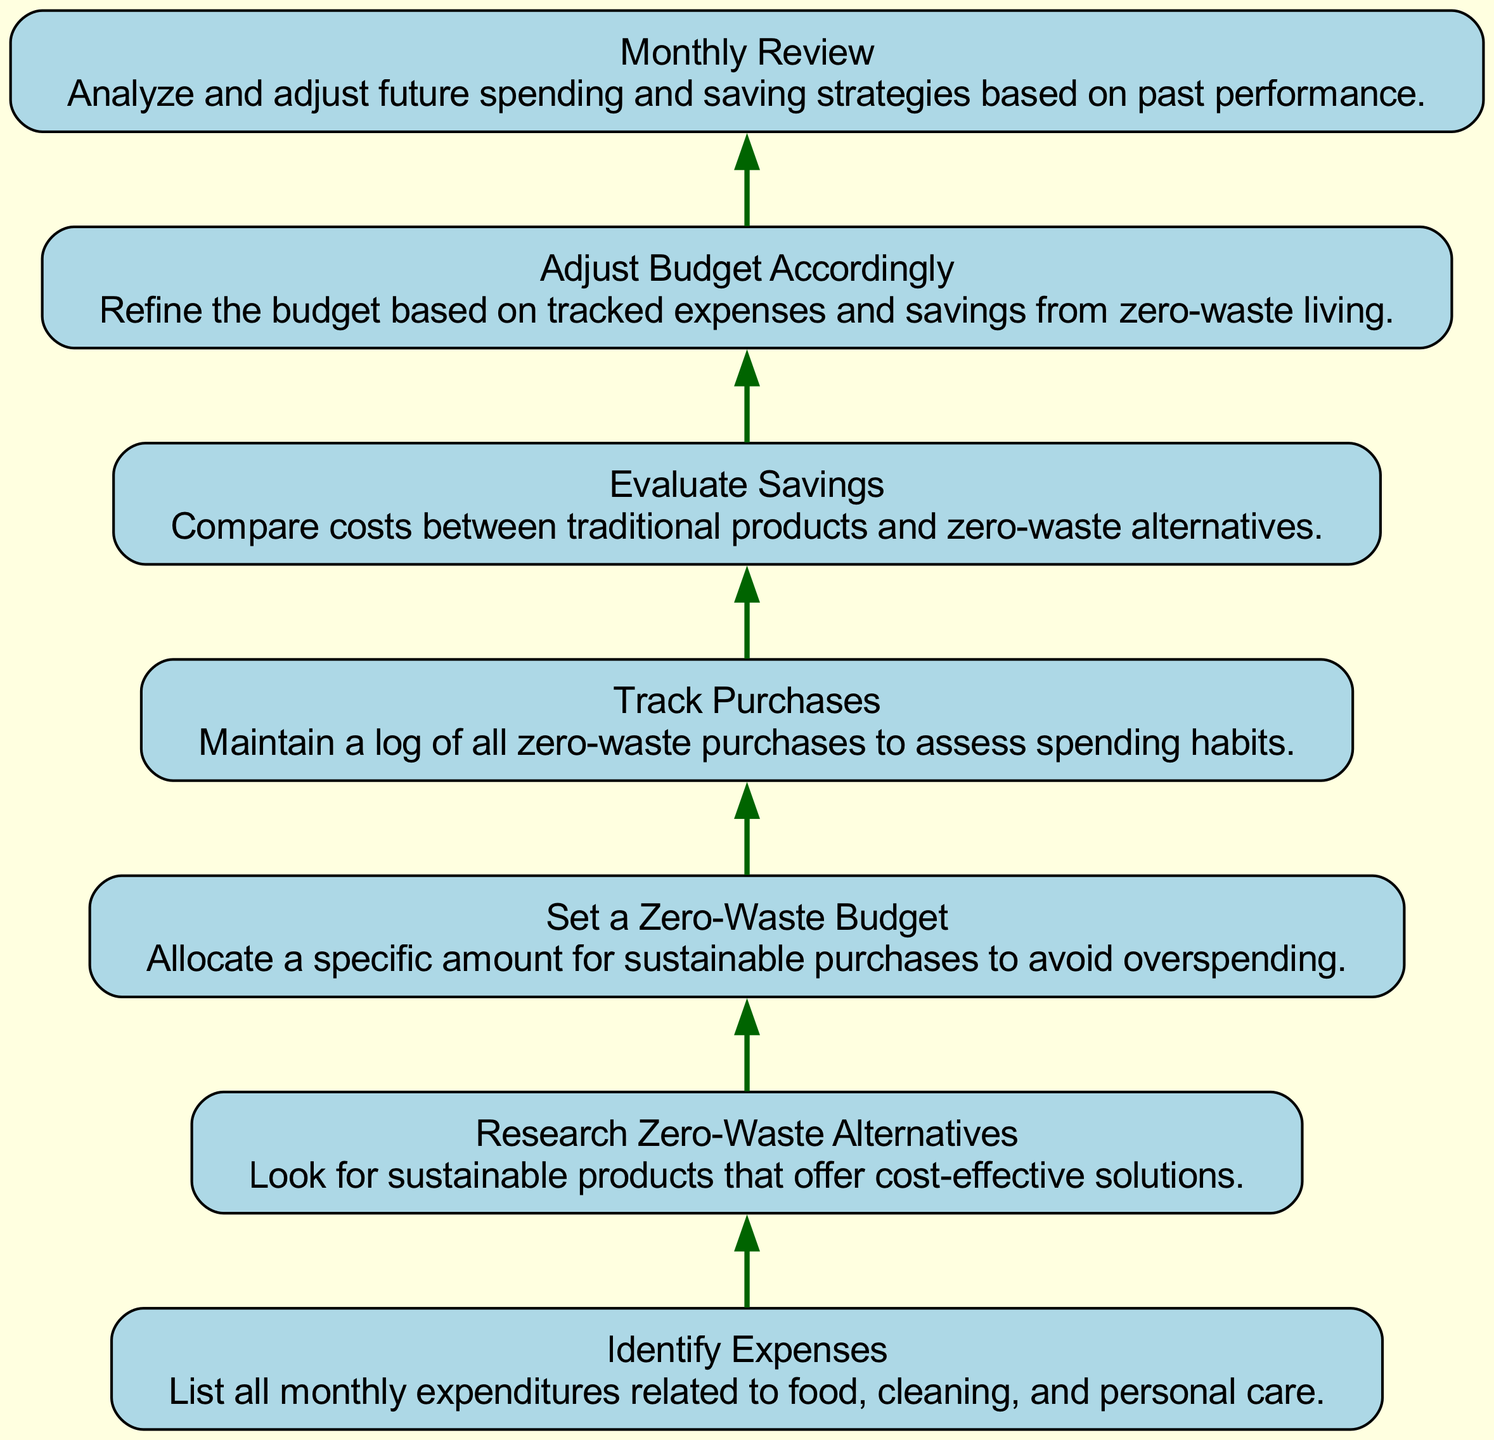What is the first step in budgeting for a zero-waste lifestyle? The first step is to identify all monthly expenses related to food, cleaning, and personal care, as indicated by the first node in the flow chart.
Answer: Identify Expenses How many nodes are in the diagram? There are seven distinct nodes representing different steps in the budgeting process for a zero-waste lifestyle.
Answer: Seven What is the last step mentioned in the flow chart? The last step is to conduct a monthly review to analyze and adjust future spending and saving strategies, as shown at the bottom of the flow chart.
Answer: Monthly Review Which two steps are connected directly before "Track Purchases"? The steps "Set a Zero-Waste Budget" and "Track Purchases" are directly connected, with the former leading into the latter in the flow chart.
Answer: Set a Zero-Waste Budget, Track Purchases Which step focuses on refining the budget? The step that focuses on refining the budget based on tracked expenses and savings is "Adjust Budget Accordingly," as indicated in the flow chart following the evaluation of savings.
Answer: Adjust Budget Accordingly What group of steps does "Evaluate Savings" connect? "Evaluate Savings" connects the steps of tracking purchases and adjusting the budget, indicating a flow where tracking informs evaluation.
Answer: Track Purchases, Adjust Budget Accordingly Which step involves looking for sustainable products? The step that involves researching sustainable products that offer cost-effective solutions is "Research Zero-Waste Alternatives," as shown in the sequence of the flow chart.
Answer: Research Zero-Waste Alternatives What happens during the "Monthly Review"? During the "Monthly Review," individuals analyze and adjust future spending and saving strategies based on past performance, as seen as the concluding action in the flow.
Answer: Analyze and adjust future strategies 